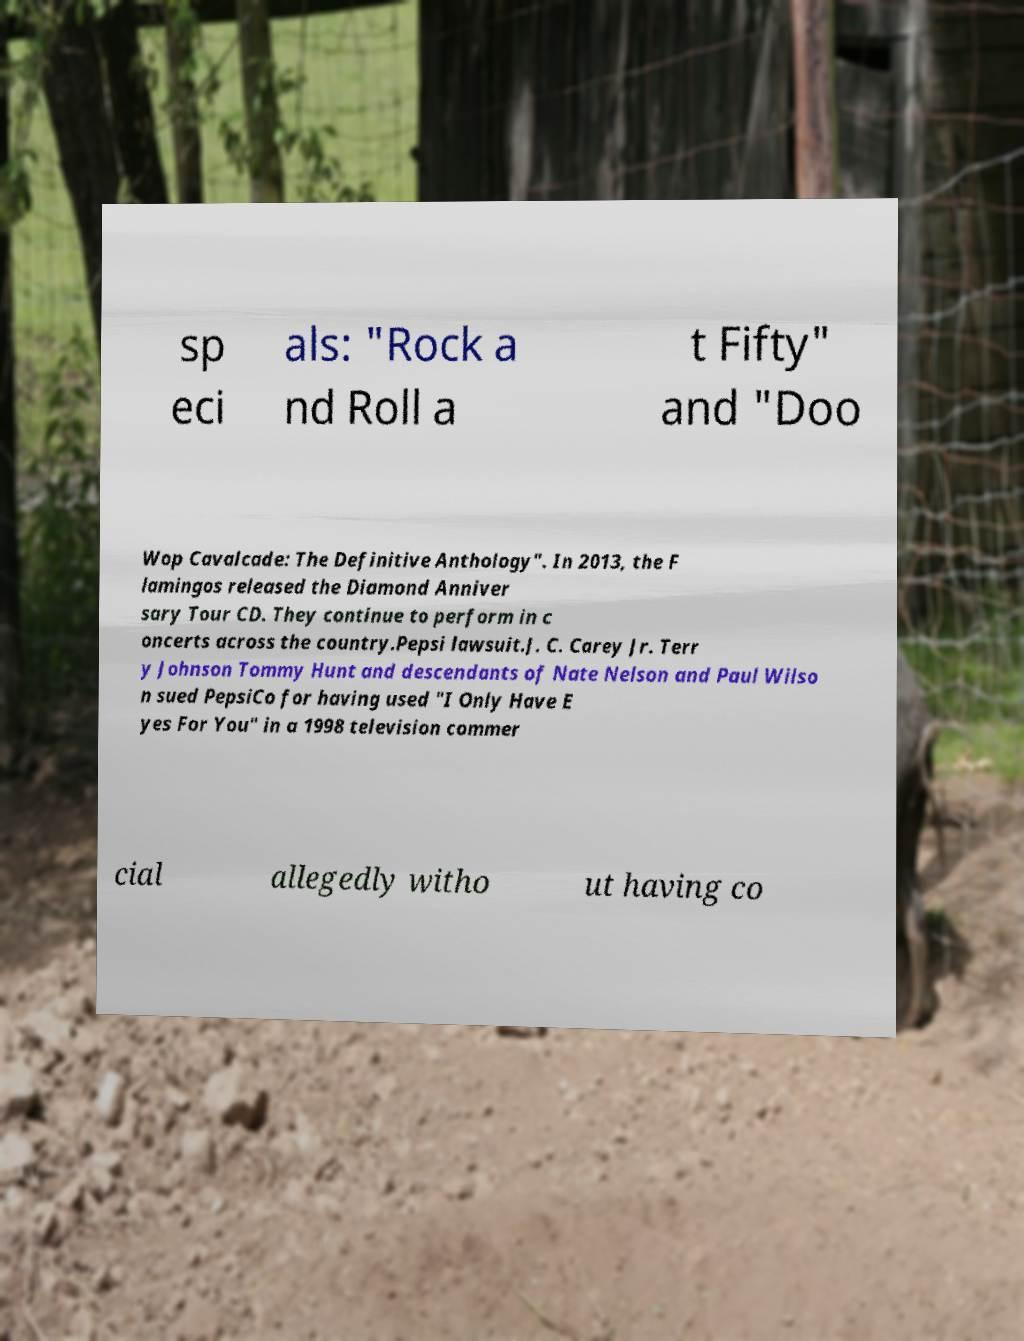Could you extract and type out the text from this image? sp eci als: "Rock a nd Roll a t Fifty" and "Doo Wop Cavalcade: The Definitive Anthology". In 2013, the F lamingos released the Diamond Anniver sary Tour CD. They continue to perform in c oncerts across the country.Pepsi lawsuit.J. C. Carey Jr. Terr y Johnson Tommy Hunt and descendants of Nate Nelson and Paul Wilso n sued PepsiCo for having used "I Only Have E yes For You" in a 1998 television commer cial allegedly witho ut having co 